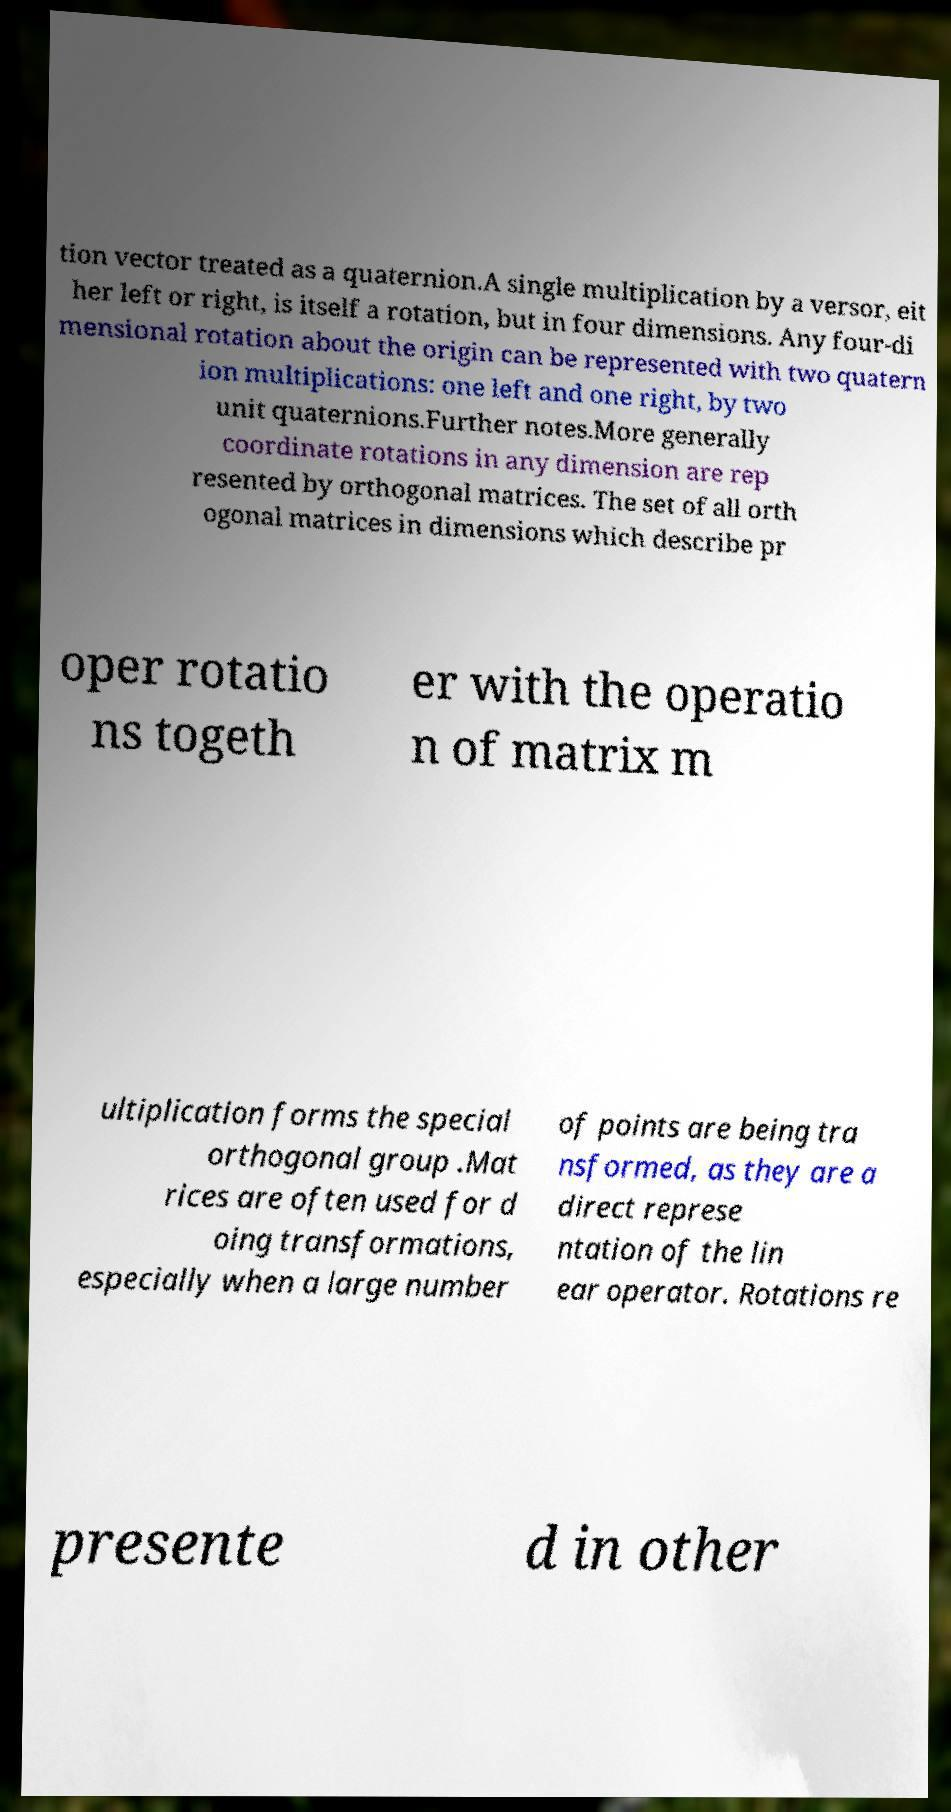Can you read and provide the text displayed in the image?This photo seems to have some interesting text. Can you extract and type it out for me? tion vector treated as a quaternion.A single multiplication by a versor, eit her left or right, is itself a rotation, but in four dimensions. Any four-di mensional rotation about the origin can be represented with two quatern ion multiplications: one left and one right, by two unit quaternions.Further notes.More generally coordinate rotations in any dimension are rep resented by orthogonal matrices. The set of all orth ogonal matrices in dimensions which describe pr oper rotatio ns togeth er with the operatio n of matrix m ultiplication forms the special orthogonal group .Mat rices are often used for d oing transformations, especially when a large number of points are being tra nsformed, as they are a direct represe ntation of the lin ear operator. Rotations re presente d in other 